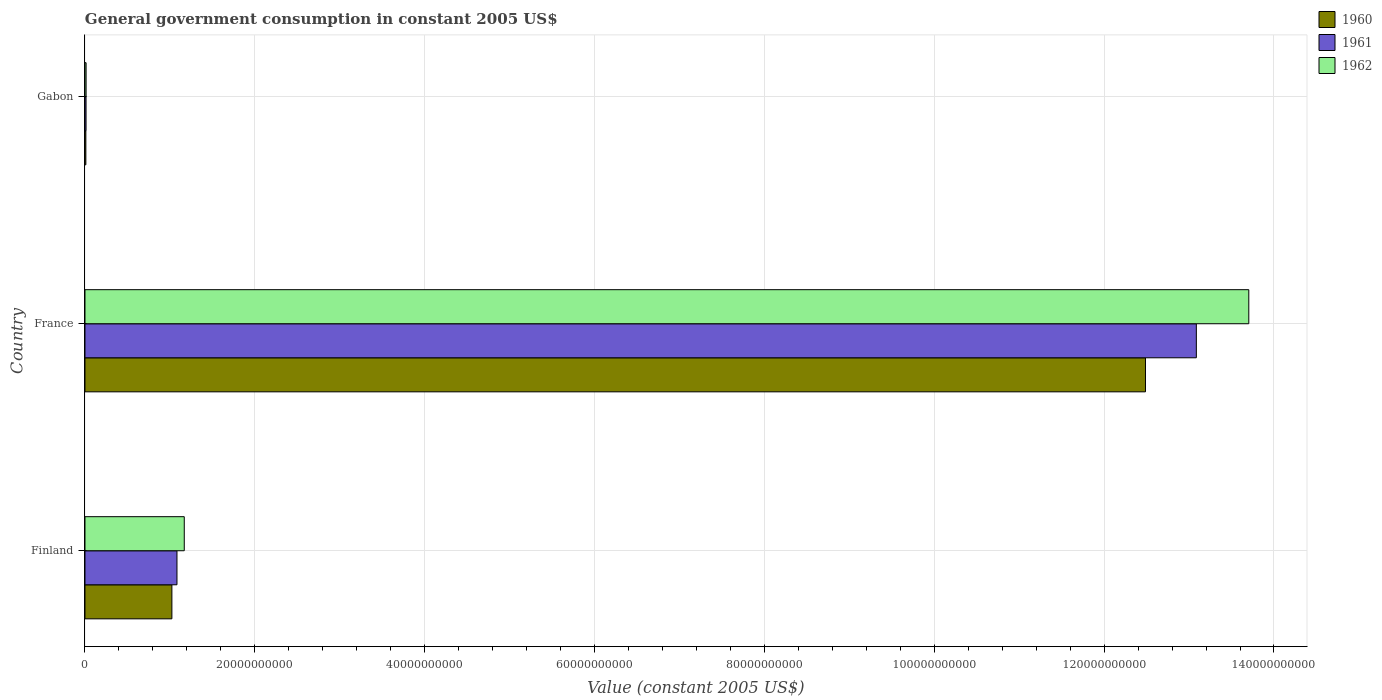Are the number of bars per tick equal to the number of legend labels?
Provide a short and direct response. Yes. How many bars are there on the 2nd tick from the top?
Keep it short and to the point. 3. How many bars are there on the 1st tick from the bottom?
Your response must be concise. 3. In how many cases, is the number of bars for a given country not equal to the number of legend labels?
Your answer should be very brief. 0. What is the government conusmption in 1960 in Finland?
Your answer should be compact. 1.02e+1. Across all countries, what is the maximum government conusmption in 1961?
Your answer should be compact. 1.31e+11. Across all countries, what is the minimum government conusmption in 1962?
Your answer should be compact. 1.31e+08. In which country was the government conusmption in 1960 minimum?
Ensure brevity in your answer.  Gabon. What is the total government conusmption in 1960 in the graph?
Offer a terse response. 1.35e+11. What is the difference between the government conusmption in 1961 in Finland and that in Gabon?
Provide a succinct answer. 1.07e+1. What is the difference between the government conusmption in 1960 in Gabon and the government conusmption in 1961 in Finland?
Give a very brief answer. -1.07e+1. What is the average government conusmption in 1960 per country?
Ensure brevity in your answer.  4.51e+1. What is the difference between the government conusmption in 1961 and government conusmption in 1962 in Gabon?
Keep it short and to the point. -4.87e+06. In how many countries, is the government conusmption in 1961 greater than 28000000000 US$?
Make the answer very short. 1. What is the ratio of the government conusmption in 1962 in Finland to that in Gabon?
Provide a succinct answer. 88.91. Is the government conusmption in 1960 in France less than that in Gabon?
Provide a short and direct response. No. What is the difference between the highest and the second highest government conusmption in 1961?
Ensure brevity in your answer.  1.20e+11. What is the difference between the highest and the lowest government conusmption in 1961?
Ensure brevity in your answer.  1.31e+11. Is the sum of the government conusmption in 1961 in Finland and France greater than the maximum government conusmption in 1960 across all countries?
Provide a succinct answer. Yes. What does the 3rd bar from the top in Gabon represents?
Keep it short and to the point. 1960. What does the 2nd bar from the bottom in Gabon represents?
Your answer should be very brief. 1961. Is it the case that in every country, the sum of the government conusmption in 1960 and government conusmption in 1961 is greater than the government conusmption in 1962?
Keep it short and to the point. Yes. Does the graph contain grids?
Provide a short and direct response. Yes. How are the legend labels stacked?
Make the answer very short. Vertical. What is the title of the graph?
Ensure brevity in your answer.  General government consumption in constant 2005 US$. What is the label or title of the X-axis?
Your answer should be very brief. Value (constant 2005 US$). What is the label or title of the Y-axis?
Your answer should be very brief. Country. What is the Value (constant 2005 US$) of 1960 in Finland?
Offer a very short reply. 1.02e+1. What is the Value (constant 2005 US$) of 1961 in Finland?
Make the answer very short. 1.08e+1. What is the Value (constant 2005 US$) in 1962 in Finland?
Make the answer very short. 1.17e+1. What is the Value (constant 2005 US$) of 1960 in France?
Give a very brief answer. 1.25e+11. What is the Value (constant 2005 US$) in 1961 in France?
Give a very brief answer. 1.31e+11. What is the Value (constant 2005 US$) of 1962 in France?
Make the answer very short. 1.37e+11. What is the Value (constant 2005 US$) in 1960 in Gabon?
Keep it short and to the point. 1.04e+08. What is the Value (constant 2005 US$) of 1961 in Gabon?
Keep it short and to the point. 1.27e+08. What is the Value (constant 2005 US$) in 1962 in Gabon?
Ensure brevity in your answer.  1.31e+08. Across all countries, what is the maximum Value (constant 2005 US$) in 1960?
Your response must be concise. 1.25e+11. Across all countries, what is the maximum Value (constant 2005 US$) in 1961?
Keep it short and to the point. 1.31e+11. Across all countries, what is the maximum Value (constant 2005 US$) in 1962?
Offer a very short reply. 1.37e+11. Across all countries, what is the minimum Value (constant 2005 US$) in 1960?
Your answer should be very brief. 1.04e+08. Across all countries, what is the minimum Value (constant 2005 US$) of 1961?
Your answer should be compact. 1.27e+08. Across all countries, what is the minimum Value (constant 2005 US$) of 1962?
Your answer should be compact. 1.31e+08. What is the total Value (constant 2005 US$) of 1960 in the graph?
Offer a terse response. 1.35e+11. What is the total Value (constant 2005 US$) of 1961 in the graph?
Your response must be concise. 1.42e+11. What is the total Value (constant 2005 US$) in 1962 in the graph?
Keep it short and to the point. 1.49e+11. What is the difference between the Value (constant 2005 US$) of 1960 in Finland and that in France?
Provide a short and direct response. -1.15e+11. What is the difference between the Value (constant 2005 US$) in 1961 in Finland and that in France?
Your response must be concise. -1.20e+11. What is the difference between the Value (constant 2005 US$) in 1962 in Finland and that in France?
Offer a very short reply. -1.25e+11. What is the difference between the Value (constant 2005 US$) of 1960 in Finland and that in Gabon?
Give a very brief answer. 1.01e+1. What is the difference between the Value (constant 2005 US$) in 1961 in Finland and that in Gabon?
Give a very brief answer. 1.07e+1. What is the difference between the Value (constant 2005 US$) of 1962 in Finland and that in Gabon?
Your answer should be very brief. 1.16e+1. What is the difference between the Value (constant 2005 US$) of 1960 in France and that in Gabon?
Offer a very short reply. 1.25e+11. What is the difference between the Value (constant 2005 US$) of 1961 in France and that in Gabon?
Your answer should be very brief. 1.31e+11. What is the difference between the Value (constant 2005 US$) of 1962 in France and that in Gabon?
Offer a terse response. 1.37e+11. What is the difference between the Value (constant 2005 US$) of 1960 in Finland and the Value (constant 2005 US$) of 1961 in France?
Your answer should be compact. -1.21e+11. What is the difference between the Value (constant 2005 US$) of 1960 in Finland and the Value (constant 2005 US$) of 1962 in France?
Your answer should be compact. -1.27e+11. What is the difference between the Value (constant 2005 US$) of 1961 in Finland and the Value (constant 2005 US$) of 1962 in France?
Provide a succinct answer. -1.26e+11. What is the difference between the Value (constant 2005 US$) of 1960 in Finland and the Value (constant 2005 US$) of 1961 in Gabon?
Provide a succinct answer. 1.01e+1. What is the difference between the Value (constant 2005 US$) of 1960 in Finland and the Value (constant 2005 US$) of 1962 in Gabon?
Provide a short and direct response. 1.01e+1. What is the difference between the Value (constant 2005 US$) in 1961 in Finland and the Value (constant 2005 US$) in 1962 in Gabon?
Keep it short and to the point. 1.07e+1. What is the difference between the Value (constant 2005 US$) in 1960 in France and the Value (constant 2005 US$) in 1961 in Gabon?
Ensure brevity in your answer.  1.25e+11. What is the difference between the Value (constant 2005 US$) of 1960 in France and the Value (constant 2005 US$) of 1962 in Gabon?
Ensure brevity in your answer.  1.25e+11. What is the difference between the Value (constant 2005 US$) of 1961 in France and the Value (constant 2005 US$) of 1962 in Gabon?
Give a very brief answer. 1.31e+11. What is the average Value (constant 2005 US$) in 1960 per country?
Your response must be concise. 4.51e+1. What is the average Value (constant 2005 US$) in 1961 per country?
Your response must be concise. 4.73e+1. What is the average Value (constant 2005 US$) of 1962 per country?
Provide a short and direct response. 4.96e+1. What is the difference between the Value (constant 2005 US$) in 1960 and Value (constant 2005 US$) in 1961 in Finland?
Give a very brief answer. -5.98e+08. What is the difference between the Value (constant 2005 US$) of 1960 and Value (constant 2005 US$) of 1962 in Finland?
Your response must be concise. -1.46e+09. What is the difference between the Value (constant 2005 US$) of 1961 and Value (constant 2005 US$) of 1962 in Finland?
Offer a terse response. -8.59e+08. What is the difference between the Value (constant 2005 US$) in 1960 and Value (constant 2005 US$) in 1961 in France?
Your answer should be very brief. -5.99e+09. What is the difference between the Value (constant 2005 US$) in 1960 and Value (constant 2005 US$) in 1962 in France?
Give a very brief answer. -1.22e+1. What is the difference between the Value (constant 2005 US$) of 1961 and Value (constant 2005 US$) of 1962 in France?
Give a very brief answer. -6.18e+09. What is the difference between the Value (constant 2005 US$) in 1960 and Value (constant 2005 US$) in 1961 in Gabon?
Ensure brevity in your answer.  -2.27e+07. What is the difference between the Value (constant 2005 US$) in 1960 and Value (constant 2005 US$) in 1962 in Gabon?
Offer a terse response. -2.76e+07. What is the difference between the Value (constant 2005 US$) in 1961 and Value (constant 2005 US$) in 1962 in Gabon?
Give a very brief answer. -4.87e+06. What is the ratio of the Value (constant 2005 US$) in 1960 in Finland to that in France?
Ensure brevity in your answer.  0.08. What is the ratio of the Value (constant 2005 US$) of 1961 in Finland to that in France?
Make the answer very short. 0.08. What is the ratio of the Value (constant 2005 US$) of 1962 in Finland to that in France?
Provide a succinct answer. 0.09. What is the ratio of the Value (constant 2005 US$) in 1960 in Finland to that in Gabon?
Provide a short and direct response. 98.5. What is the ratio of the Value (constant 2005 US$) in 1961 in Finland to that in Gabon?
Your response must be concise. 85.55. What is the ratio of the Value (constant 2005 US$) in 1962 in Finland to that in Gabon?
Offer a terse response. 88.91. What is the ratio of the Value (constant 2005 US$) in 1960 in France to that in Gabon?
Your response must be concise. 1201.88. What is the ratio of the Value (constant 2005 US$) in 1961 in France to that in Gabon?
Ensure brevity in your answer.  1033.44. What is the ratio of the Value (constant 2005 US$) of 1962 in France to that in Gabon?
Make the answer very short. 1042.14. What is the difference between the highest and the second highest Value (constant 2005 US$) in 1960?
Provide a succinct answer. 1.15e+11. What is the difference between the highest and the second highest Value (constant 2005 US$) of 1961?
Your answer should be very brief. 1.20e+11. What is the difference between the highest and the second highest Value (constant 2005 US$) in 1962?
Provide a short and direct response. 1.25e+11. What is the difference between the highest and the lowest Value (constant 2005 US$) of 1960?
Offer a very short reply. 1.25e+11. What is the difference between the highest and the lowest Value (constant 2005 US$) in 1961?
Provide a succinct answer. 1.31e+11. What is the difference between the highest and the lowest Value (constant 2005 US$) of 1962?
Offer a very short reply. 1.37e+11. 